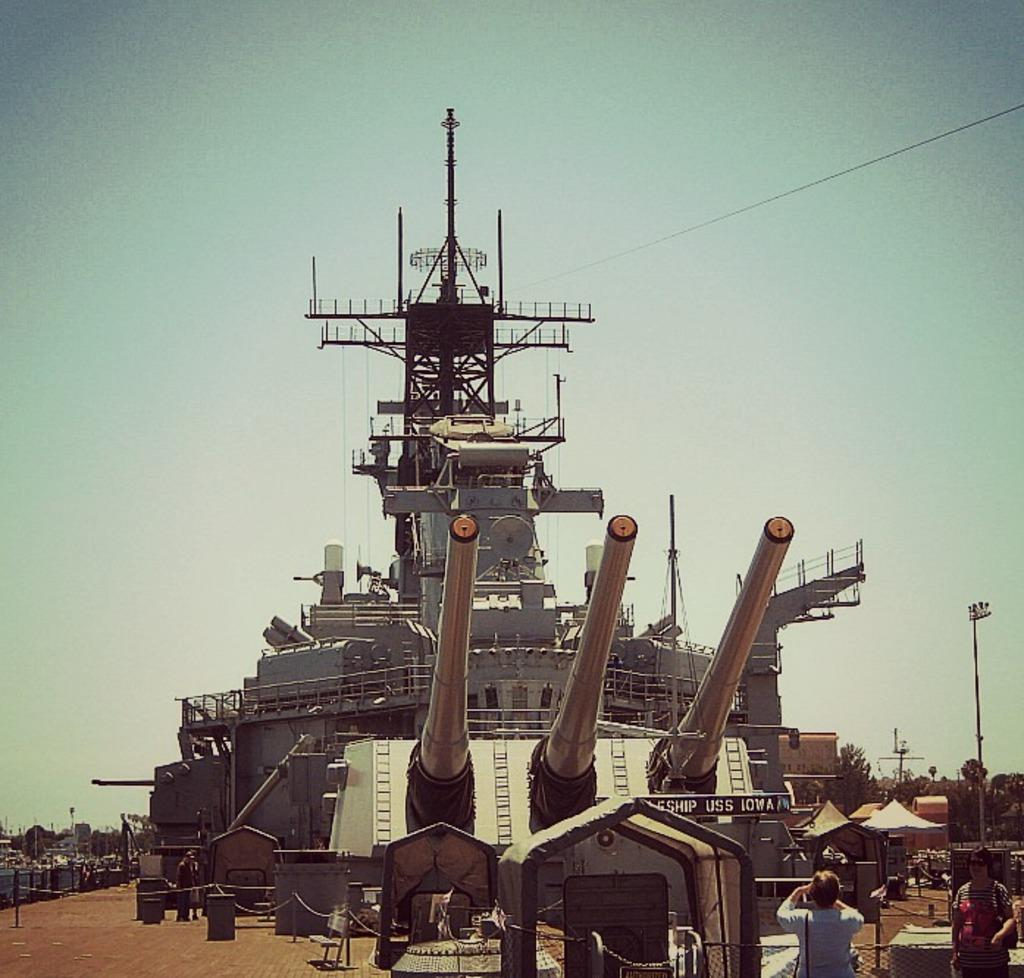What is the main subject of the picture? The main subject of the picture is a ship. What are the cannons used for in the picture? The cannons are likely used for defense or as a decorative feature on the ship. What are the people standing on the ground doing in the picture? The people standing on the ground may be observing the ship or performing other activities. What is the purpose of the fence in the picture? The fence may serve as a boundary or to provide security around the area. What are the poles and wires used for in the picture? The poles and wires may be part of a utility infrastructure, such as power lines or telecommunications. What other objects can be seen on the ground in the picture? There are other objects on the ground, but their specific purpose or function cannot be determined from the provided facts. What can be seen in the background of the picture? In the background of the picture, there are trees and the sky visible. What type of cloud is floating above the ship in the picture? There is no cloud visible in the picture; only the sky is visible in the background. What ornament is hanging from the ship's mast in the picture? There is no ornament hanging from the ship's mast in the picture; only the ship, cannons, people, fence, poles, wires, and other objects on the ground are present. 